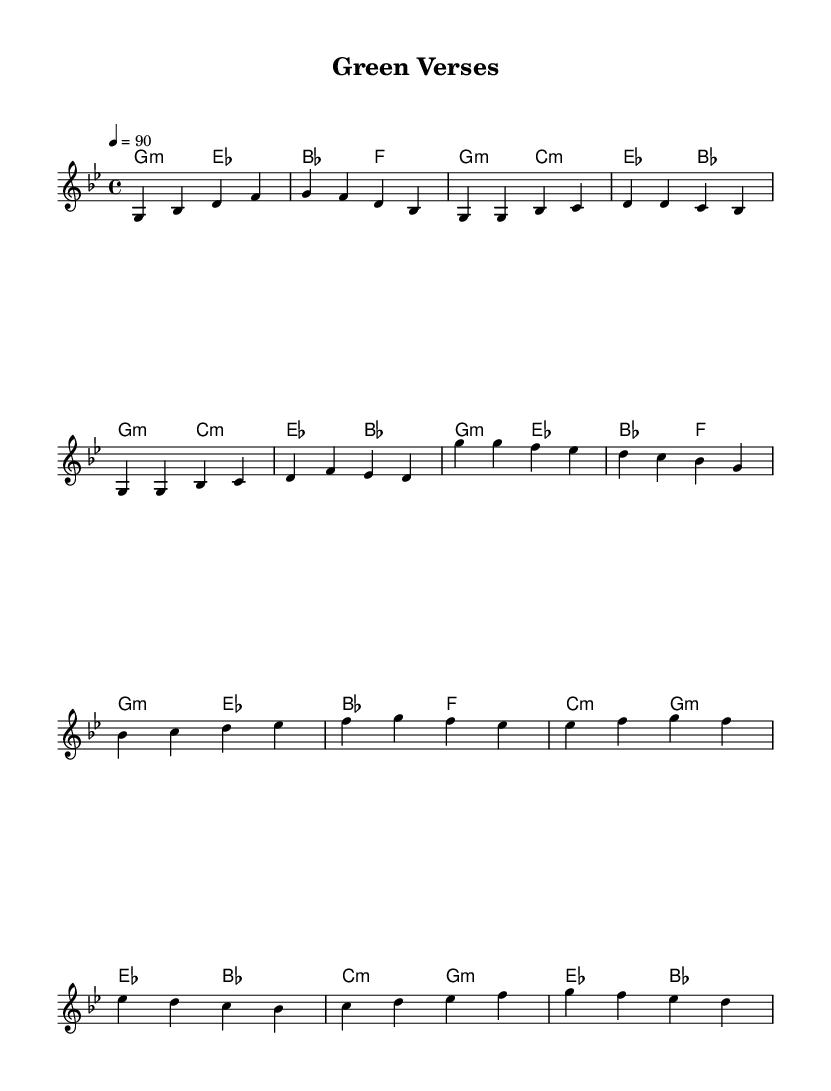What is the key signature of this music? The key signature is indicated as G minor, which includes two flats (B flat and E flat). This is determined from the key signature symbol placed at the beginning of the staff.
Answer: G minor What is the time signature of this piece? The time signature is 4/4, which means there are four beats per measure and a quarter note receives one beat. This is shown at the beginning of the score.
Answer: 4/4 What is the tempo marking for this piece? The tempo is marked as 4 = 90, meaning there are 90 beats per minute, with each quarter note receiving one beat. This appears at the beginning of the score right after the time signature.
Answer: 90 How many measures are in the chorus section? The chorus consists of four measures based on the repeated sequence shown on the sheet music. Counting the measures that are labeled as chorus provides the total.
Answer: 4 What type of harmonic structure is predominantly used in this piece? The harmonic structure primarily features minor chords, specifically G minor and E flat major. This can be identified by analyzing the chord symbols written above the staff throughout the piece.
Answer: Minor What themes does the piece address based on its content? The piece conveys themes of environmental consciousness and climate change. This is inferred from the title "Green Verses" and the specific lyrics or content typically found in conscious hip hop focusing on these issues.
Answer: Environmental consciousness Which musical genre does this piece belong to? This piece is classified as conscious hip hop, characterized by its focus on social issues and environmental themes, which is a defining aspect of this genre of music.
Answer: Conscious hip hop 